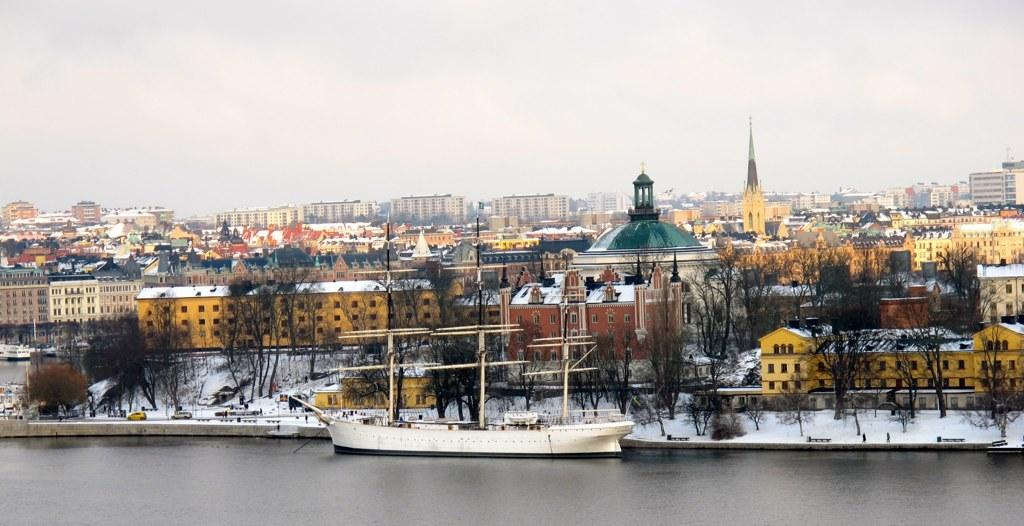What is present at the bottom of the image? There is water at the bottom side of the image. What structures can be seen in the image? There are buildings in the image. What type of vegetation is present in the image? There are trees in the image. What type of vehicles can be seen in the image? There are cars in the image. What is the ground covered with in the image? The ground is covered in snow. What type of religion is being practiced in the image? There is no indication of any religious practice in the image. What type of cake can be seen in the image? There is no cake present in the image. 